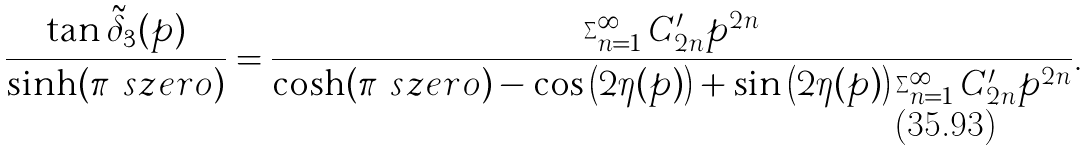<formula> <loc_0><loc_0><loc_500><loc_500>\frac { \tan \tilde { \delta } _ { 3 } ( p ) } { \sinh ( \pi \ s z e r o ) } = \frac { \sum _ { n = 1 } ^ { \infty } C ^ { \prime } _ { 2 n } p ^ { 2 n } } { \cosh ( \pi \ s z e r o ) - \cos \left ( 2 \eta ( p ) \right ) + \sin \left ( 2 \eta ( p ) \right ) \sum _ { n = 1 } ^ { \infty } C ^ { \prime } _ { 2 n } p ^ { 2 n } } .</formula> 